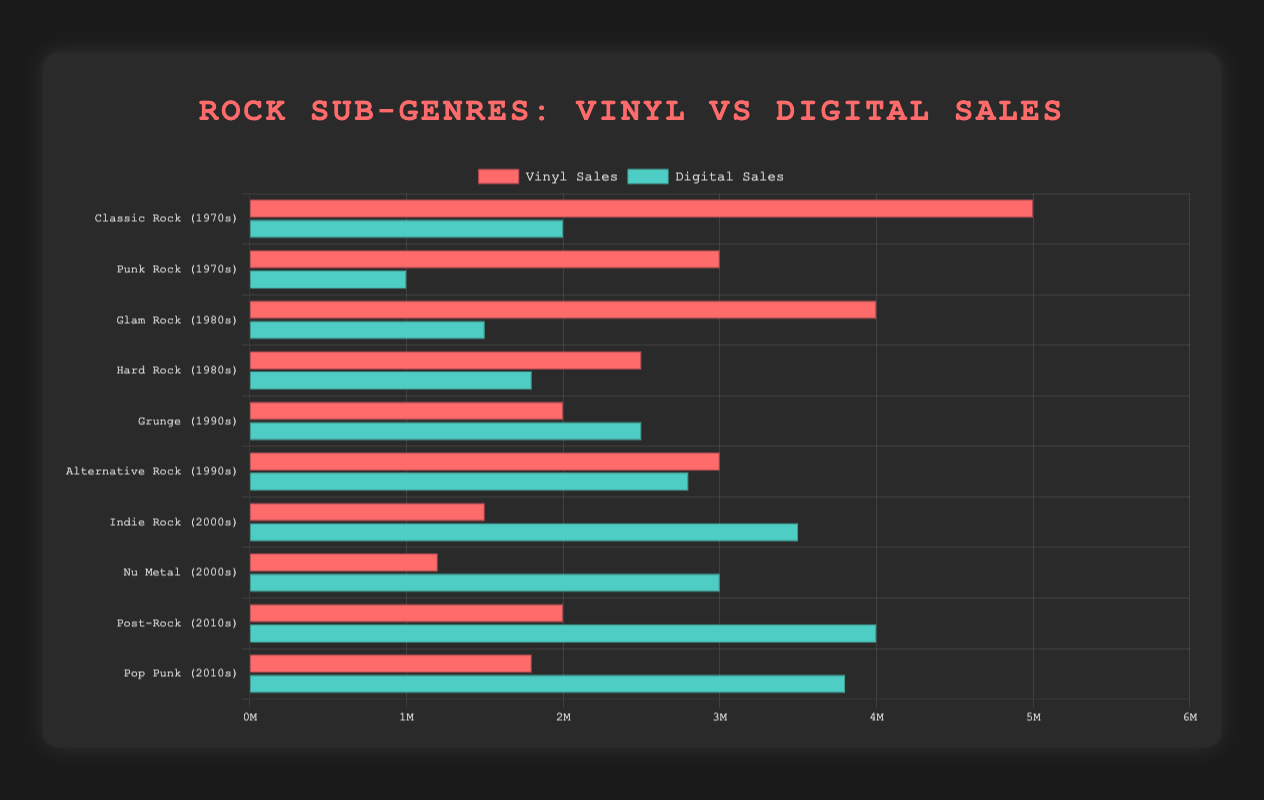Which sub-genre had the highest vinyl sales in the 1970s? Observe the heights of the bars labeled with 1970s. The "Classic Rock (1970s)" bar for vinyl sales is taller than the "Punk Rock (1970s)" bar.
Answer: Classic Rock Which sub-genre had a greater difference between vinyl and digital sales in the 2010s? Compare the heights of vinyl and digital bars for "Post-Rock (2010s)" and "Pop Punk (2010s)". For "Post-Rock (2010s)", the difference is 4000000 - 2000000 = 2000000. For "Pop Punk (2010s)", the difference is 3800000 - 1800000 = 2000000. Both differences are the same.
Answer: Both are equal Which decade exhibited the least digital sales among listed sub-genres? Identify the digital sales bars for each decade, then determine the lowest value. The digital sales order from lowest to highest are: Punk Rock (1970s), Hard Rock (1980s), Glam Rock (1980s), Classic Rock (1970s), Grunge (1990s), Alternative Rock (1990s), Nu Metal (2000s), Indie Rock (2000s), Pop Punk (2010s), Post-Rock (2010s). The least is Punk Rock in the 1970s.
Answer: 1970s Which decade saw vinyl sales higher than digital sales for most sub-genres? Count the number of sub-genres per decade where vinyl sales bars are taller than digital sales bars. In the 1970s, Classic Rock and Punk Rock both have higher vinyl sales. In the 1980s, Glam Rock has higher vinyl but Hard Rock has lower. In the 1990s onwards, vinyl sales are generally lower than digital.
Answer: 1970s In which sub-genre did digital sales surpass vinyl sales by the largest margin? Compare height differences across all bars. The largest is "Post-Rock (2010s)" where digital sales far exceed vinyl by 4000000 - 2000000 = 2000000.
Answer: Post-Rock Which sub-genre showed the closest sales numbers between vinyl and digital formats? Look for pairs where the vinyl and digital bars are almost the same height. "Alternative Rock (1990s)" shows both vinyl and digital sales close to each other, with 3000000 vinyl and 2800000 digital, a difference of 200000.
Answer: Alternative Rock스 Which two sub-genres have the combined highest vinyl sales in the 2000s? Add the vinyl sales for "Indie Rock (2000s)" and "Nu Metal (2000s)". "Indie Rock (2000s)" is 1500000 and "Nu Metal (2000s)" is 1200000. The combined sales are 1500000 + 1200000 = 2700000.
Answer: Indie Rock and Nu Metal 